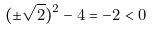Convert formula to latex. <formula><loc_0><loc_0><loc_500><loc_500>( \pm \sqrt { 2 } ) ^ { 2 } - 4 = - 2 < 0</formula> 